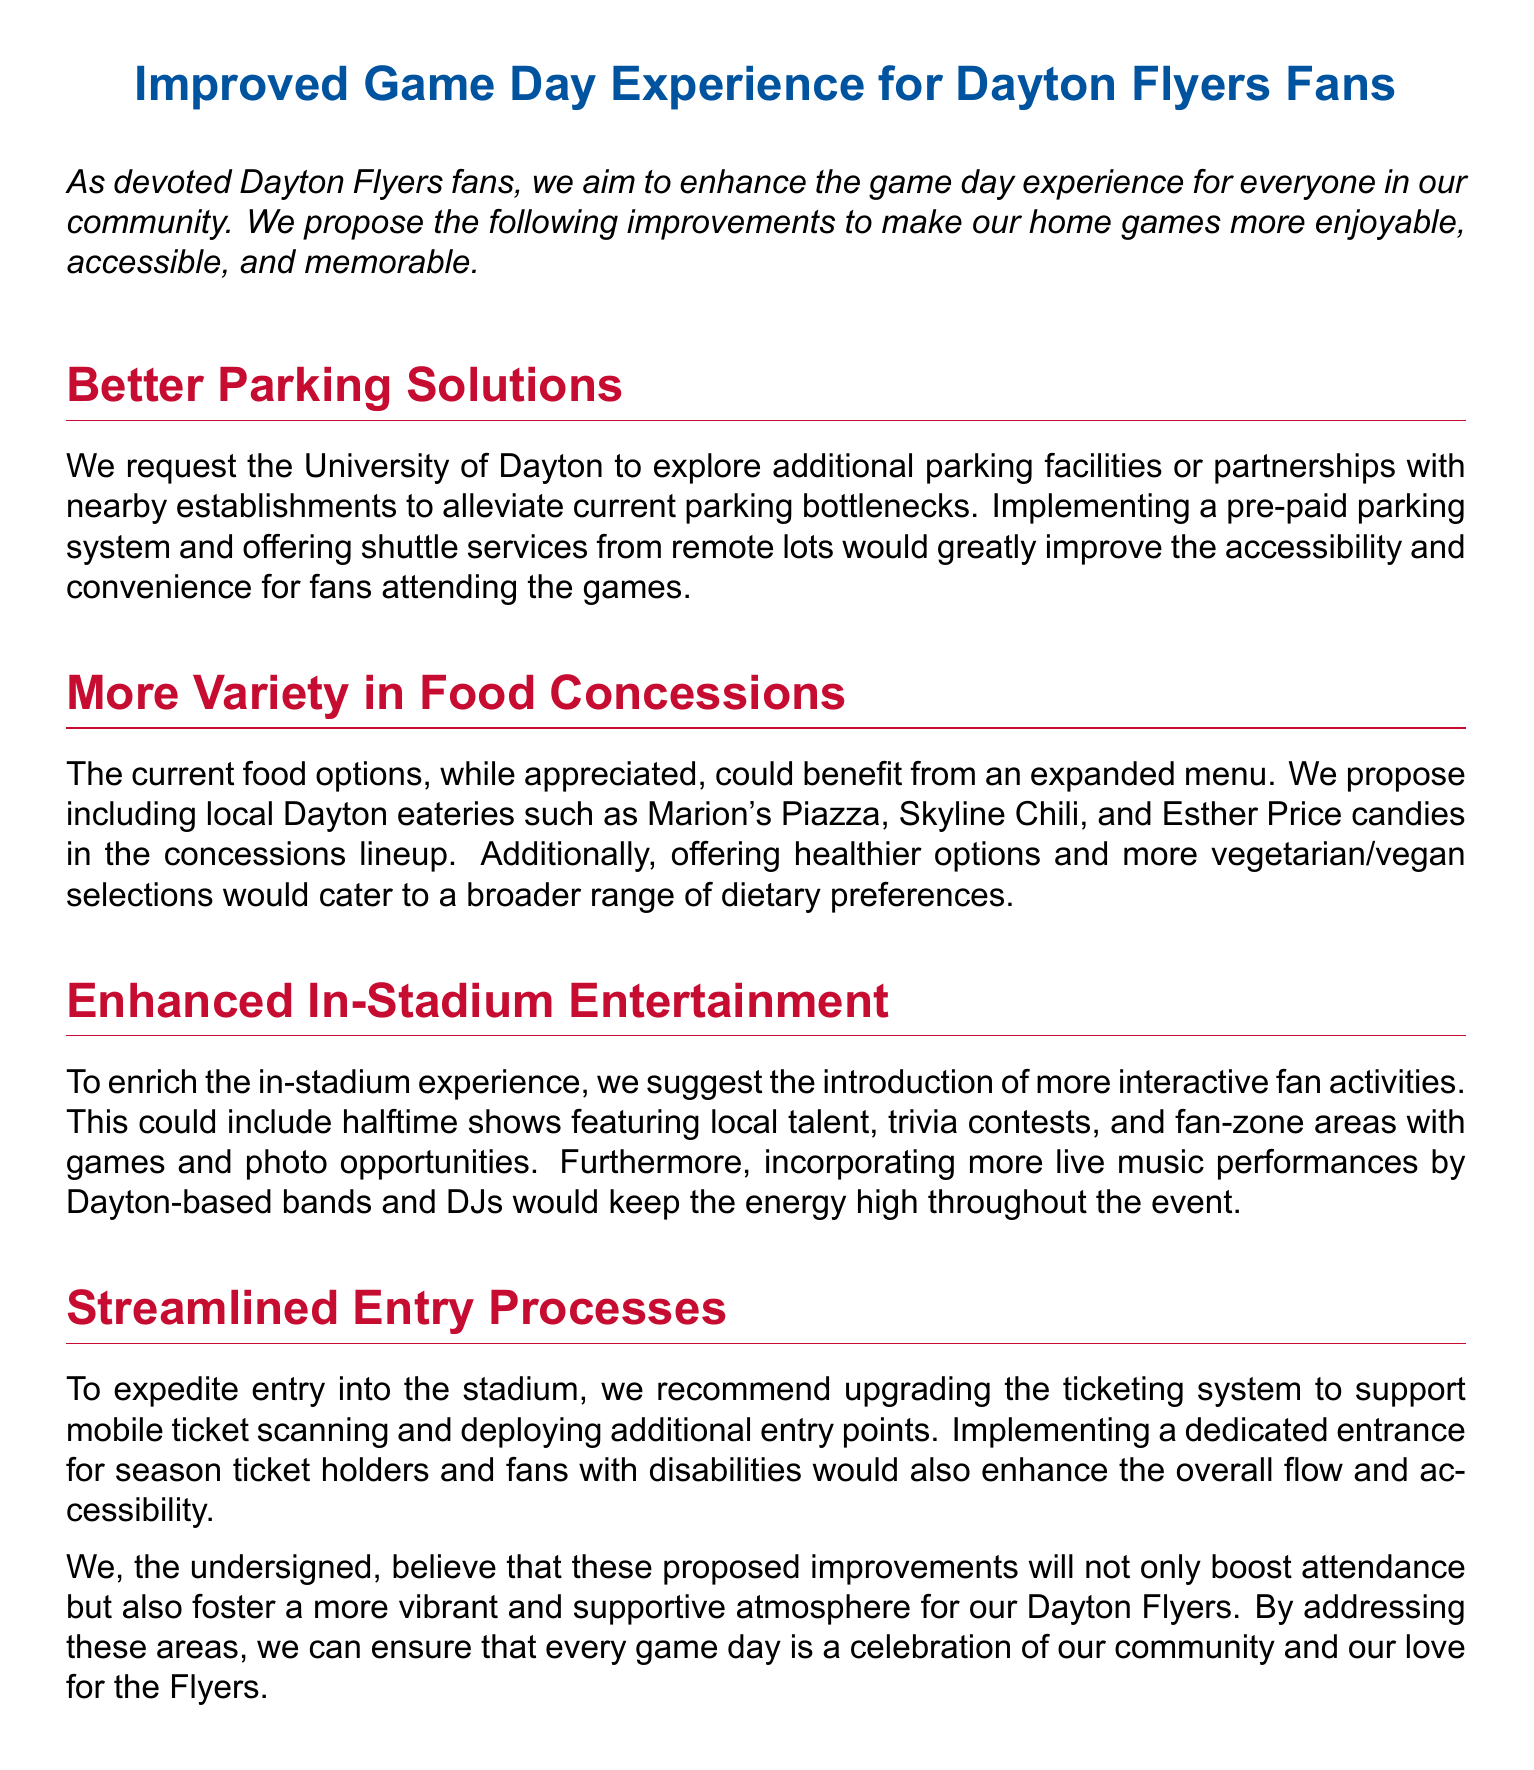What is the title of the petition? The title of the petition is the main heading and states the intent of the document clearly.
Answer: Improved Game Day Experience for Dayton Flyers Fans What are the two specific food options proposed in the petition? The petition lists specific local eateries to be included in the concessions lineup providing variety.
Answer: Marion's Piazza, Skyline Chili How many areas for improvement are mentioned in the petition? The number of distinct sections in the petition indicates the areas of enhancement suggested for the game day experience.
Answer: Four What is one suggested method for improving parking solutions? The document outlines specific proposals for addressing parking issues at games, including various solutions.
Answer: Pre-paid parking system What type of entertainment is suggested to enhance the in-stadium experience? The document suggests various forms of in-stadium entertainment to make the experience more interactive and enjoyable.
Answer: Halftime shows What is one proposed change to streamline entry processes? The petition recommends specific actions to enhance the efficiency of entering the stadium for fans.
Answer: Mobile ticket scanning What is the main purpose of this petition? The intent behind this document is clearly stated in the introduction, summarizing the goal for the game day experiences.
Answer: Enhance game day experience How is the document structured? The layout of the petition indicates the organized way in which suggestions are presented to improve the game day experience.
Answer: Sections with headers 